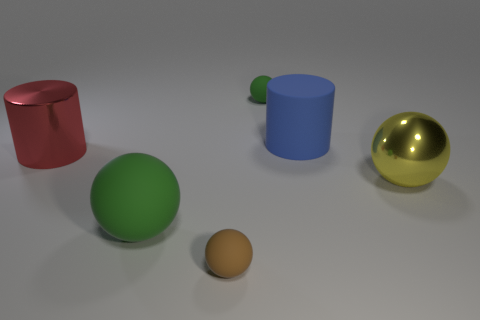Subtract all balls. How many objects are left? 2 Subtract 2 cylinders. How many cylinders are left? 0 Subtract all red cylinders. Subtract all cyan balls. How many cylinders are left? 1 Subtract all blue spheres. How many red cylinders are left? 1 Subtract all large rubber things. Subtract all big metallic cylinders. How many objects are left? 3 Add 2 yellow metal balls. How many yellow metal balls are left? 3 Add 5 large purple shiny objects. How many large purple shiny objects exist? 5 Add 1 big rubber balls. How many objects exist? 7 Subtract all blue cylinders. How many cylinders are left? 1 Subtract all yellow metal spheres. How many spheres are left? 3 